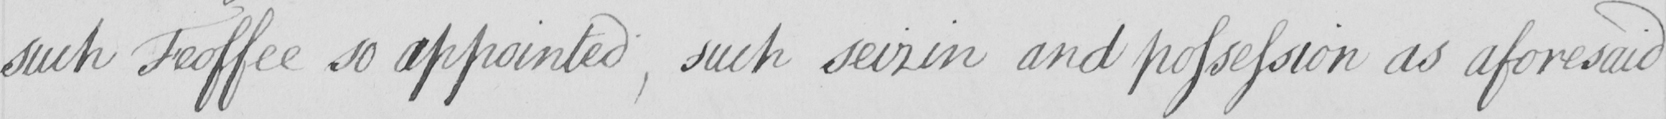What text is written in this handwritten line? such Feoffee so appointed , such seizin and possession as aforesaid 